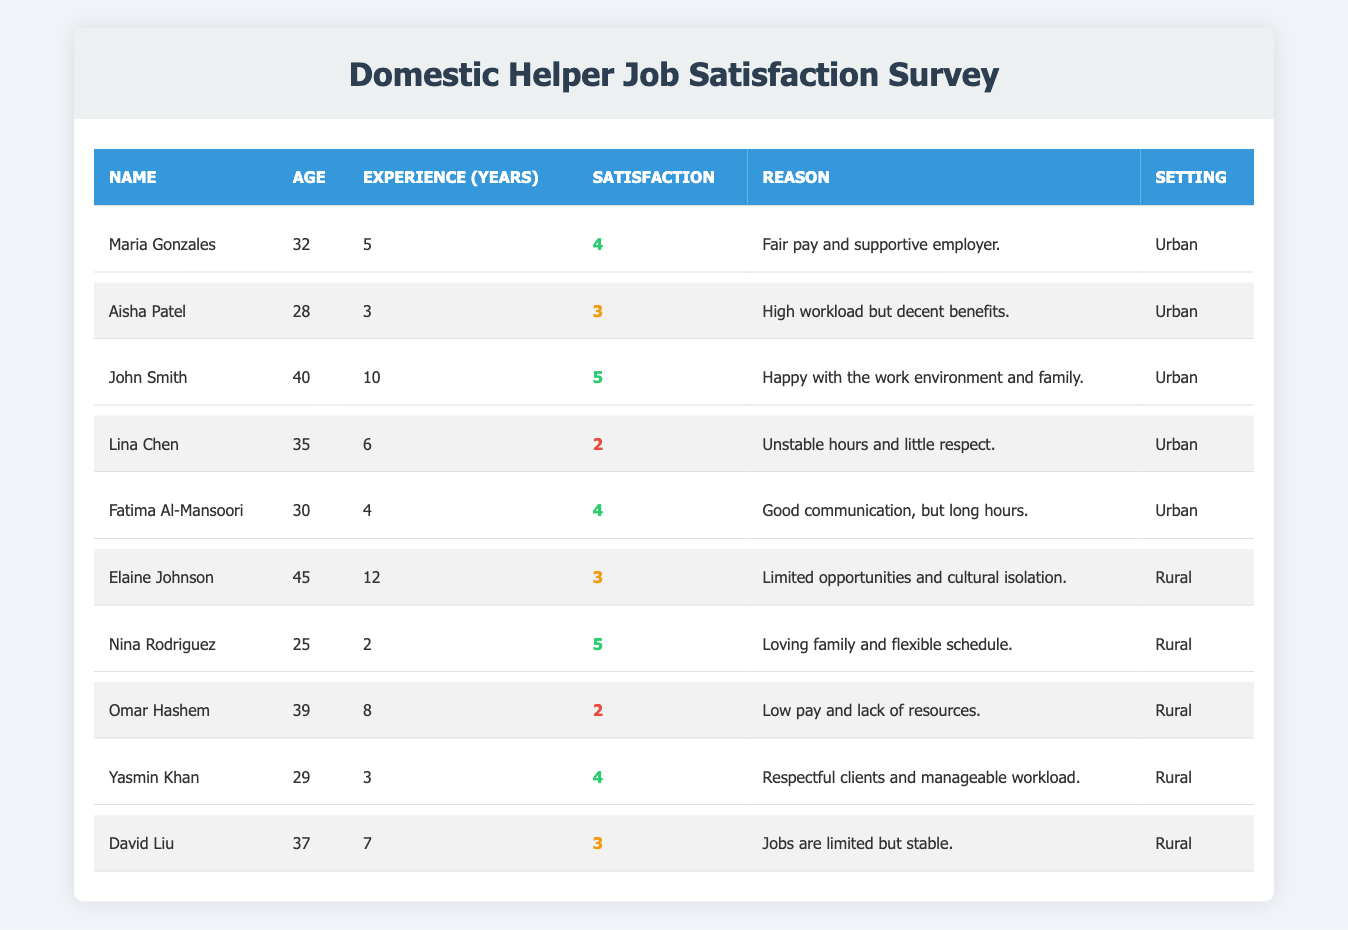What is the satisfaction rating of John Smith? John Smith's satisfaction rating can be found directly in the table under his entry. It shows a rating of 5.
Answer: 5 How many urban helpers have a satisfaction rating of 4 or higher? Count the entries in the urban section with satisfaction ratings of 4 and 5. The names are Maria Gonzales, John Smith, and Fatima Al-Mansoori. There are 3 helpers.
Answer: 3 What is the average satisfaction rating of rural helpers? The satisfaction ratings for rural helpers are 3, 5, 2, 4, and 3. Adding them gives 17, and dividing by the number of helpers (5) gives an average of 3.4.
Answer: 3.4 Is there any urban helper with a satisfaction rating of 2? Inspect the urban helpers in the table, and see that Lina Chen has a satisfaction rating of 2. Therefore, the answer is yes.
Answer: Yes Which group has a higher average satisfaction rating: urban or rural? Calculate the average for urban helpers: (4 + 3 + 5 + 2 + 4) = 18, with an average of 18/5 = 3.6. Then for rural helpers: (3 + 5 + 2 + 4 + 3) = 17, with an average of 17/5 = 3.4. Urban helpers have a higher average.
Answer: Urban What is the most common reason for low satisfaction among urban helpers? Examine the reasons for those with low ratings (2). Lina Chen stated "Unstable hours and little respect," which reflects a common concern that might lead to low satisfaction in inner-city environments.
Answer: Unstable hours and little respect How many years of experience does the urban helper with the highest satisfaction have? Find John Smith's entry in the urban section; he has 10 years of experience.
Answer: 10 Which helper has the least years of experience in the rural setting? Check the rural helpers. Nina Rodriguez has the least with 2 years of experience.
Answer: 2 What is the overall trend in satisfaction ratings between urban and rural settings? Calculate and compare the averages: urban helpers have 3.6 (higher) and rural helpers have 3.4. This indicates a slight trend towards higher satisfaction among urban helpers.
Answer: Higher in urban settings Are there more urban or rural helpers with a satisfaction rating of 3? Look at urban helpers; Aisha Patel and Lina Chen have a rating of 3 (two total). In rural, Elaine Johnson, David Liu have a rating of 3 (two total). Thus, both settings have the same amount of helpers with this rating.
Answer: Equal What reason did the rural helper with the highest satisfaction rate give? Nina Rodriguez rated her satisfaction as 5 and mentioned "Loving family and flexible schedule" as her reason.
Answer: Loving family and flexible schedule 